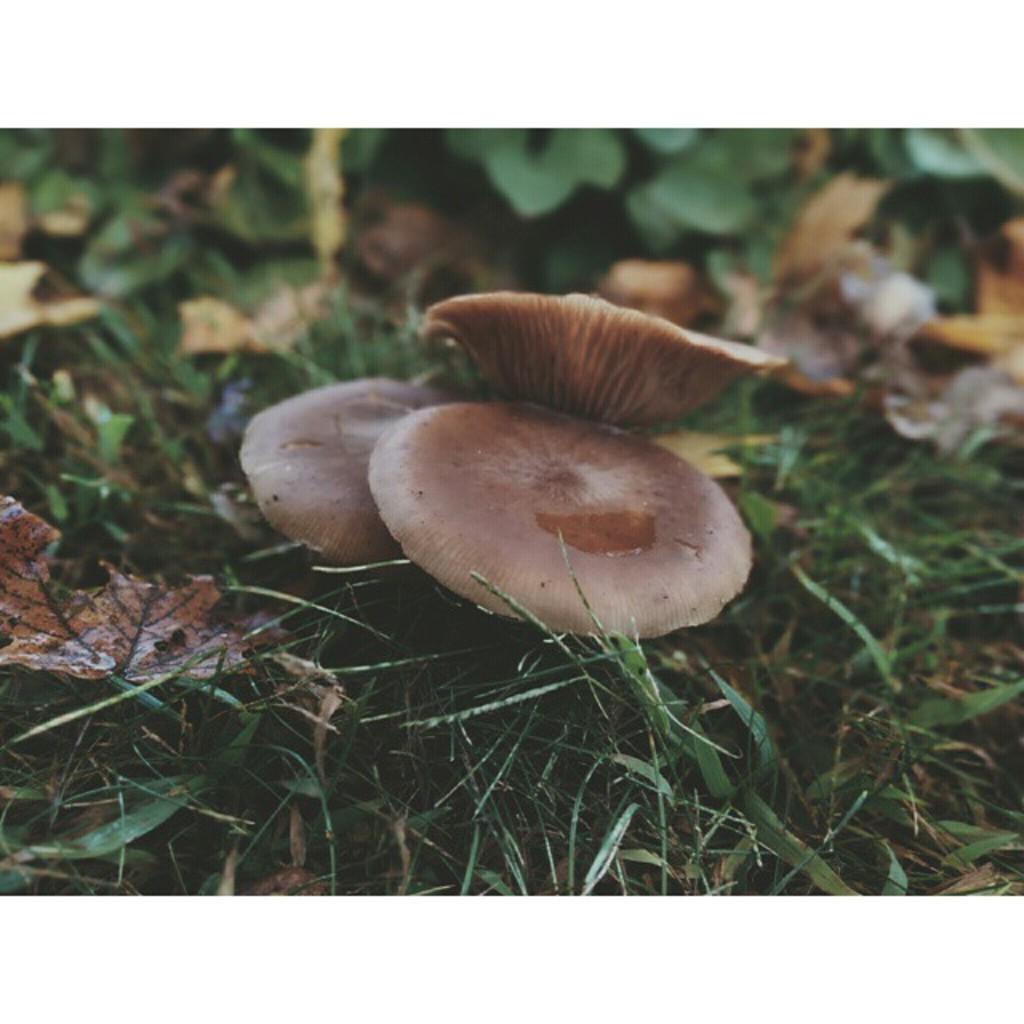Can you describe this image briefly? In the center of the image we can see mushrooms, which are in brown color. In the background, we can see the grass, plants, dry leaves and a few other objects. 